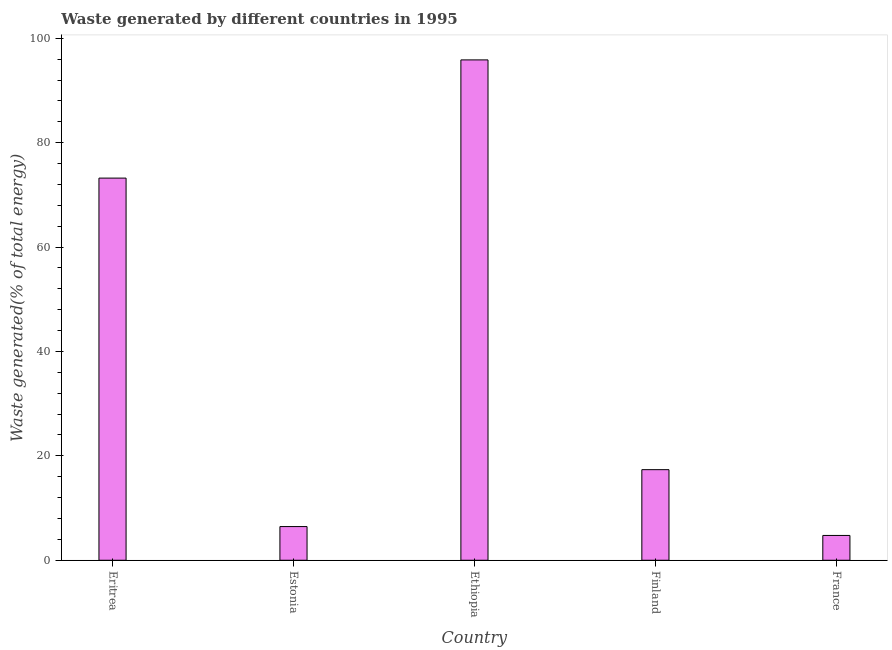Does the graph contain any zero values?
Offer a terse response. No. Does the graph contain grids?
Offer a very short reply. No. What is the title of the graph?
Your response must be concise. Waste generated by different countries in 1995. What is the label or title of the Y-axis?
Offer a terse response. Waste generated(% of total energy). What is the amount of waste generated in Eritrea?
Your answer should be compact. 73.21. Across all countries, what is the maximum amount of waste generated?
Keep it short and to the point. 95.85. Across all countries, what is the minimum amount of waste generated?
Keep it short and to the point. 4.75. In which country was the amount of waste generated maximum?
Provide a short and direct response. Ethiopia. In which country was the amount of waste generated minimum?
Your answer should be compact. France. What is the sum of the amount of waste generated?
Make the answer very short. 197.62. What is the difference between the amount of waste generated in Eritrea and France?
Ensure brevity in your answer.  68.45. What is the average amount of waste generated per country?
Provide a short and direct response. 39.52. What is the median amount of waste generated?
Your answer should be compact. 17.35. What is the ratio of the amount of waste generated in Ethiopia to that in Finland?
Offer a very short reply. 5.52. Is the difference between the amount of waste generated in Eritrea and France greater than the difference between any two countries?
Your response must be concise. No. What is the difference between the highest and the second highest amount of waste generated?
Provide a short and direct response. 22.64. Is the sum of the amount of waste generated in Estonia and Ethiopia greater than the maximum amount of waste generated across all countries?
Keep it short and to the point. Yes. What is the difference between the highest and the lowest amount of waste generated?
Your answer should be compact. 91.1. In how many countries, is the amount of waste generated greater than the average amount of waste generated taken over all countries?
Your response must be concise. 2. Are all the bars in the graph horizontal?
Provide a short and direct response. No. How many countries are there in the graph?
Offer a terse response. 5. Are the values on the major ticks of Y-axis written in scientific E-notation?
Make the answer very short. No. What is the Waste generated(% of total energy) of Eritrea?
Give a very brief answer. 73.21. What is the Waste generated(% of total energy) in Estonia?
Ensure brevity in your answer.  6.45. What is the Waste generated(% of total energy) of Ethiopia?
Ensure brevity in your answer.  95.85. What is the Waste generated(% of total energy) of Finland?
Provide a succinct answer. 17.35. What is the Waste generated(% of total energy) in France?
Give a very brief answer. 4.75. What is the difference between the Waste generated(% of total energy) in Eritrea and Estonia?
Give a very brief answer. 66.75. What is the difference between the Waste generated(% of total energy) in Eritrea and Ethiopia?
Ensure brevity in your answer.  -22.64. What is the difference between the Waste generated(% of total energy) in Eritrea and Finland?
Make the answer very short. 55.85. What is the difference between the Waste generated(% of total energy) in Eritrea and France?
Give a very brief answer. 68.45. What is the difference between the Waste generated(% of total energy) in Estonia and Ethiopia?
Your response must be concise. -89.4. What is the difference between the Waste generated(% of total energy) in Estonia and Finland?
Your answer should be very brief. -10.9. What is the difference between the Waste generated(% of total energy) in Estonia and France?
Your answer should be very brief. 1.7. What is the difference between the Waste generated(% of total energy) in Ethiopia and Finland?
Make the answer very short. 78.5. What is the difference between the Waste generated(% of total energy) in Ethiopia and France?
Provide a short and direct response. 91.1. What is the difference between the Waste generated(% of total energy) in Finland and France?
Keep it short and to the point. 12.6. What is the ratio of the Waste generated(% of total energy) in Eritrea to that in Estonia?
Ensure brevity in your answer.  11.34. What is the ratio of the Waste generated(% of total energy) in Eritrea to that in Ethiopia?
Your response must be concise. 0.76. What is the ratio of the Waste generated(% of total energy) in Eritrea to that in Finland?
Provide a succinct answer. 4.22. What is the ratio of the Waste generated(% of total energy) in Estonia to that in Ethiopia?
Your response must be concise. 0.07. What is the ratio of the Waste generated(% of total energy) in Estonia to that in Finland?
Offer a very short reply. 0.37. What is the ratio of the Waste generated(% of total energy) in Estonia to that in France?
Make the answer very short. 1.36. What is the ratio of the Waste generated(% of total energy) in Ethiopia to that in Finland?
Offer a terse response. 5.52. What is the ratio of the Waste generated(% of total energy) in Ethiopia to that in France?
Your answer should be compact. 20.16. What is the ratio of the Waste generated(% of total energy) in Finland to that in France?
Ensure brevity in your answer.  3.65. 